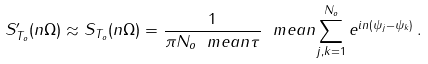<formula> <loc_0><loc_0><loc_500><loc_500>S _ { T _ { o } } ^ { \prime } ( n \Omega ) \approx S _ { T _ { o } } ( n \Omega ) = \frac { 1 } { \pi N _ { o } \ m e a n { \tau } } \ m e a n { \sum _ { j , k = 1 } ^ { N _ { o } } e ^ { i n ( \psi _ { j } - \psi _ { k } ) } } \, .</formula> 